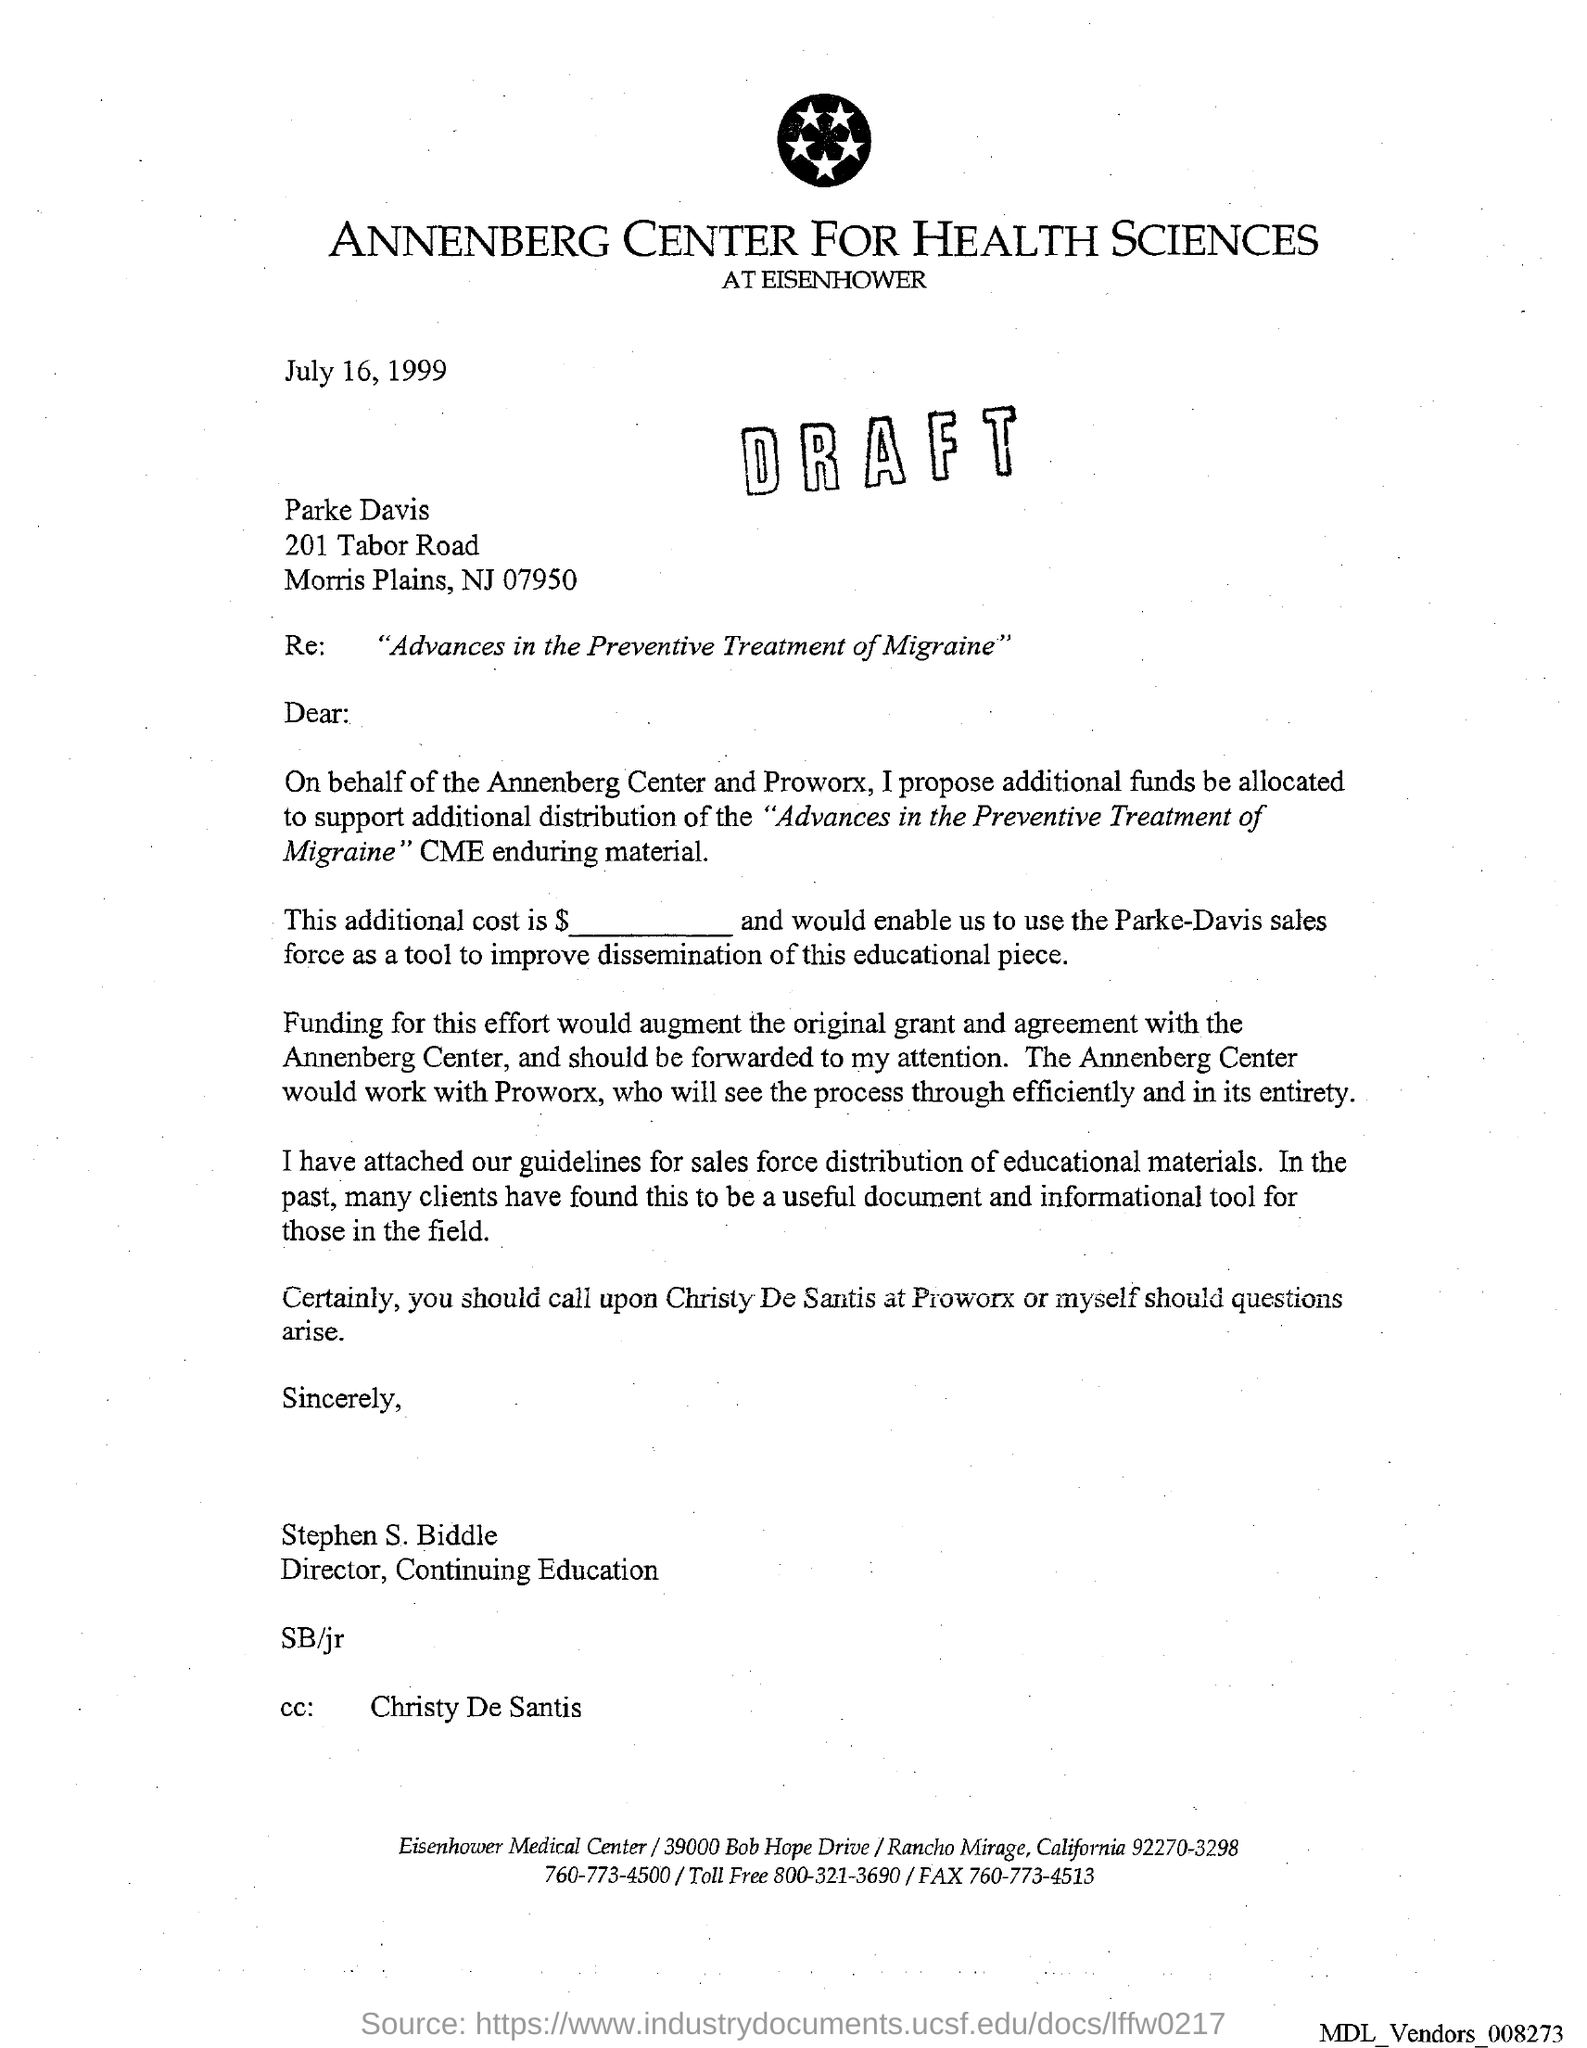Highlight a few significant elements in this photo. The issued date of this letter is July 16, 1999, as stated in the text. The letter head mentions Annenberg Center For Health Sciences, a company. Stephen S. Biddle is the sender of this letter. The recipient of this letter is marked as 'Christy De Santis' in the cc field. 